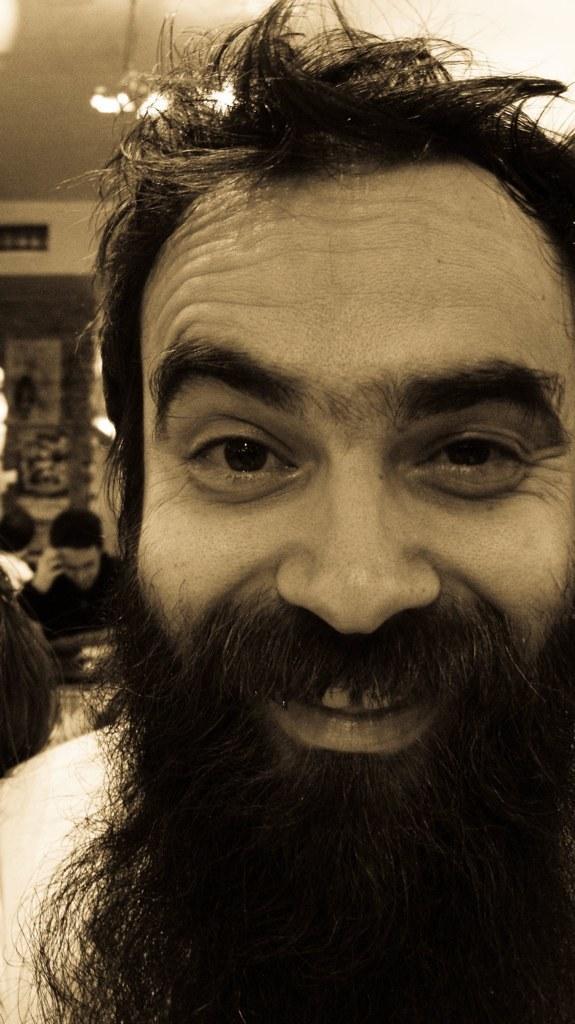Describe this image in one or two sentences. In this image I can see a person with long beard which is black in color. In the background I can see few other persons, the wall, the ceiling and few lights. 